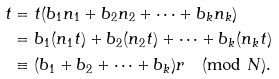<formula> <loc_0><loc_0><loc_500><loc_500>t & = t ( b _ { 1 } n _ { 1 } + b _ { 2 } n _ { 2 } + \cdots + b _ { k } n _ { k } ) \\ & = b _ { 1 } ( n _ { 1 } t ) + b _ { 2 } ( n _ { 2 } t ) + \cdots + b _ { k } ( n _ { k } t ) \\ & \equiv ( b _ { 1 } + b _ { 2 } + \cdots + b _ { k } ) r \pmod { N } .</formula> 